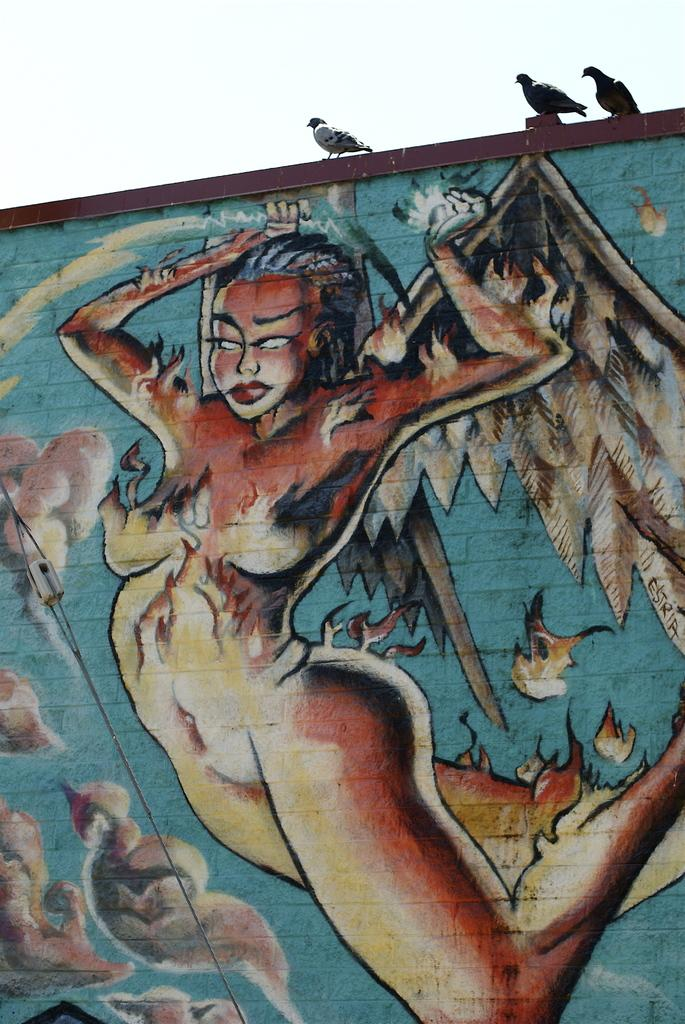What is present on the wall in the image? There is a painting of a person on the wall. Are there any other objects or living beings on the wall? Yes, there are three birds sitting on the wall. What is the condition of the sky in the image? The sky is clear in the image. Where is the lunchroom located in the image? There is no mention of a lunchroom in the image, so its location cannot be determined. What emotion does the person in the painting feel about the top? The image does not provide any information about the person's emotions or the meaning of the word "top" in relation to the painting, so it cannot be answered. 